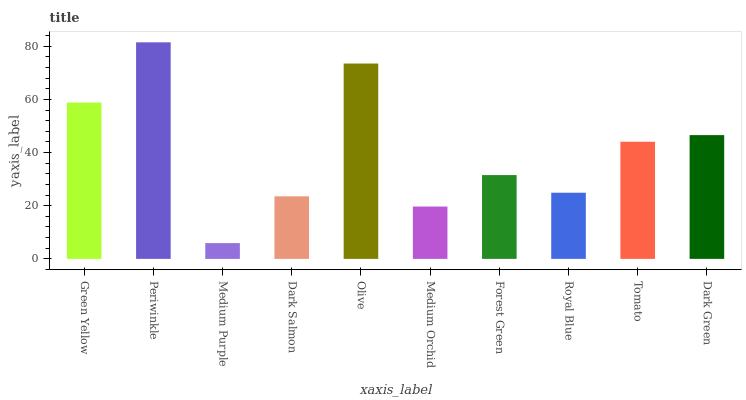Is Medium Purple the minimum?
Answer yes or no. Yes. Is Periwinkle the maximum?
Answer yes or no. Yes. Is Periwinkle the minimum?
Answer yes or no. No. Is Medium Purple the maximum?
Answer yes or no. No. Is Periwinkle greater than Medium Purple?
Answer yes or no. Yes. Is Medium Purple less than Periwinkle?
Answer yes or no. Yes. Is Medium Purple greater than Periwinkle?
Answer yes or no. No. Is Periwinkle less than Medium Purple?
Answer yes or no. No. Is Tomato the high median?
Answer yes or no. Yes. Is Forest Green the low median?
Answer yes or no. Yes. Is Royal Blue the high median?
Answer yes or no. No. Is Royal Blue the low median?
Answer yes or no. No. 